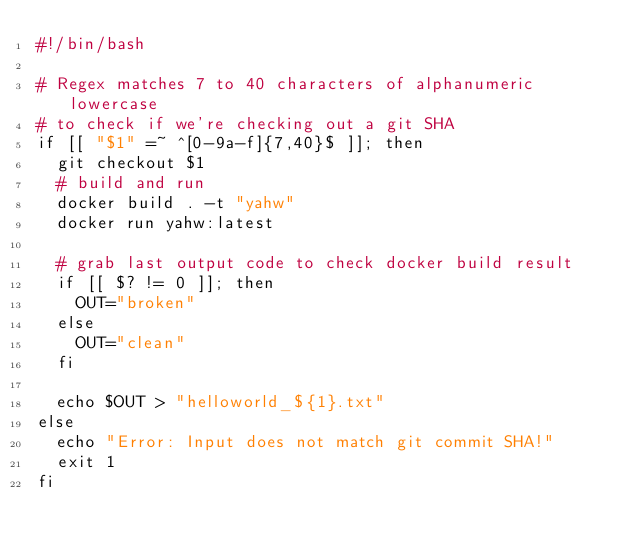<code> <loc_0><loc_0><loc_500><loc_500><_Bash_>#!/bin/bash

# Regex matches 7 to 40 characters of alphanumeric lowercase
# to check if we're checking out a git SHA
if [[ "$1" =~ ^[0-9a-f]{7,40}$ ]]; then
  git checkout $1
  # build and run
  docker build . -t "yahw"
  docker run yahw:latest

  # grab last output code to check docker build result
  if [[ $? != 0 ]]; then
    OUT="broken"
  else
    OUT="clean"
  fi

  echo $OUT > "helloworld_${1}.txt"
else
  echo "Error: Input does not match git commit SHA!"
  exit 1
fi
</code> 